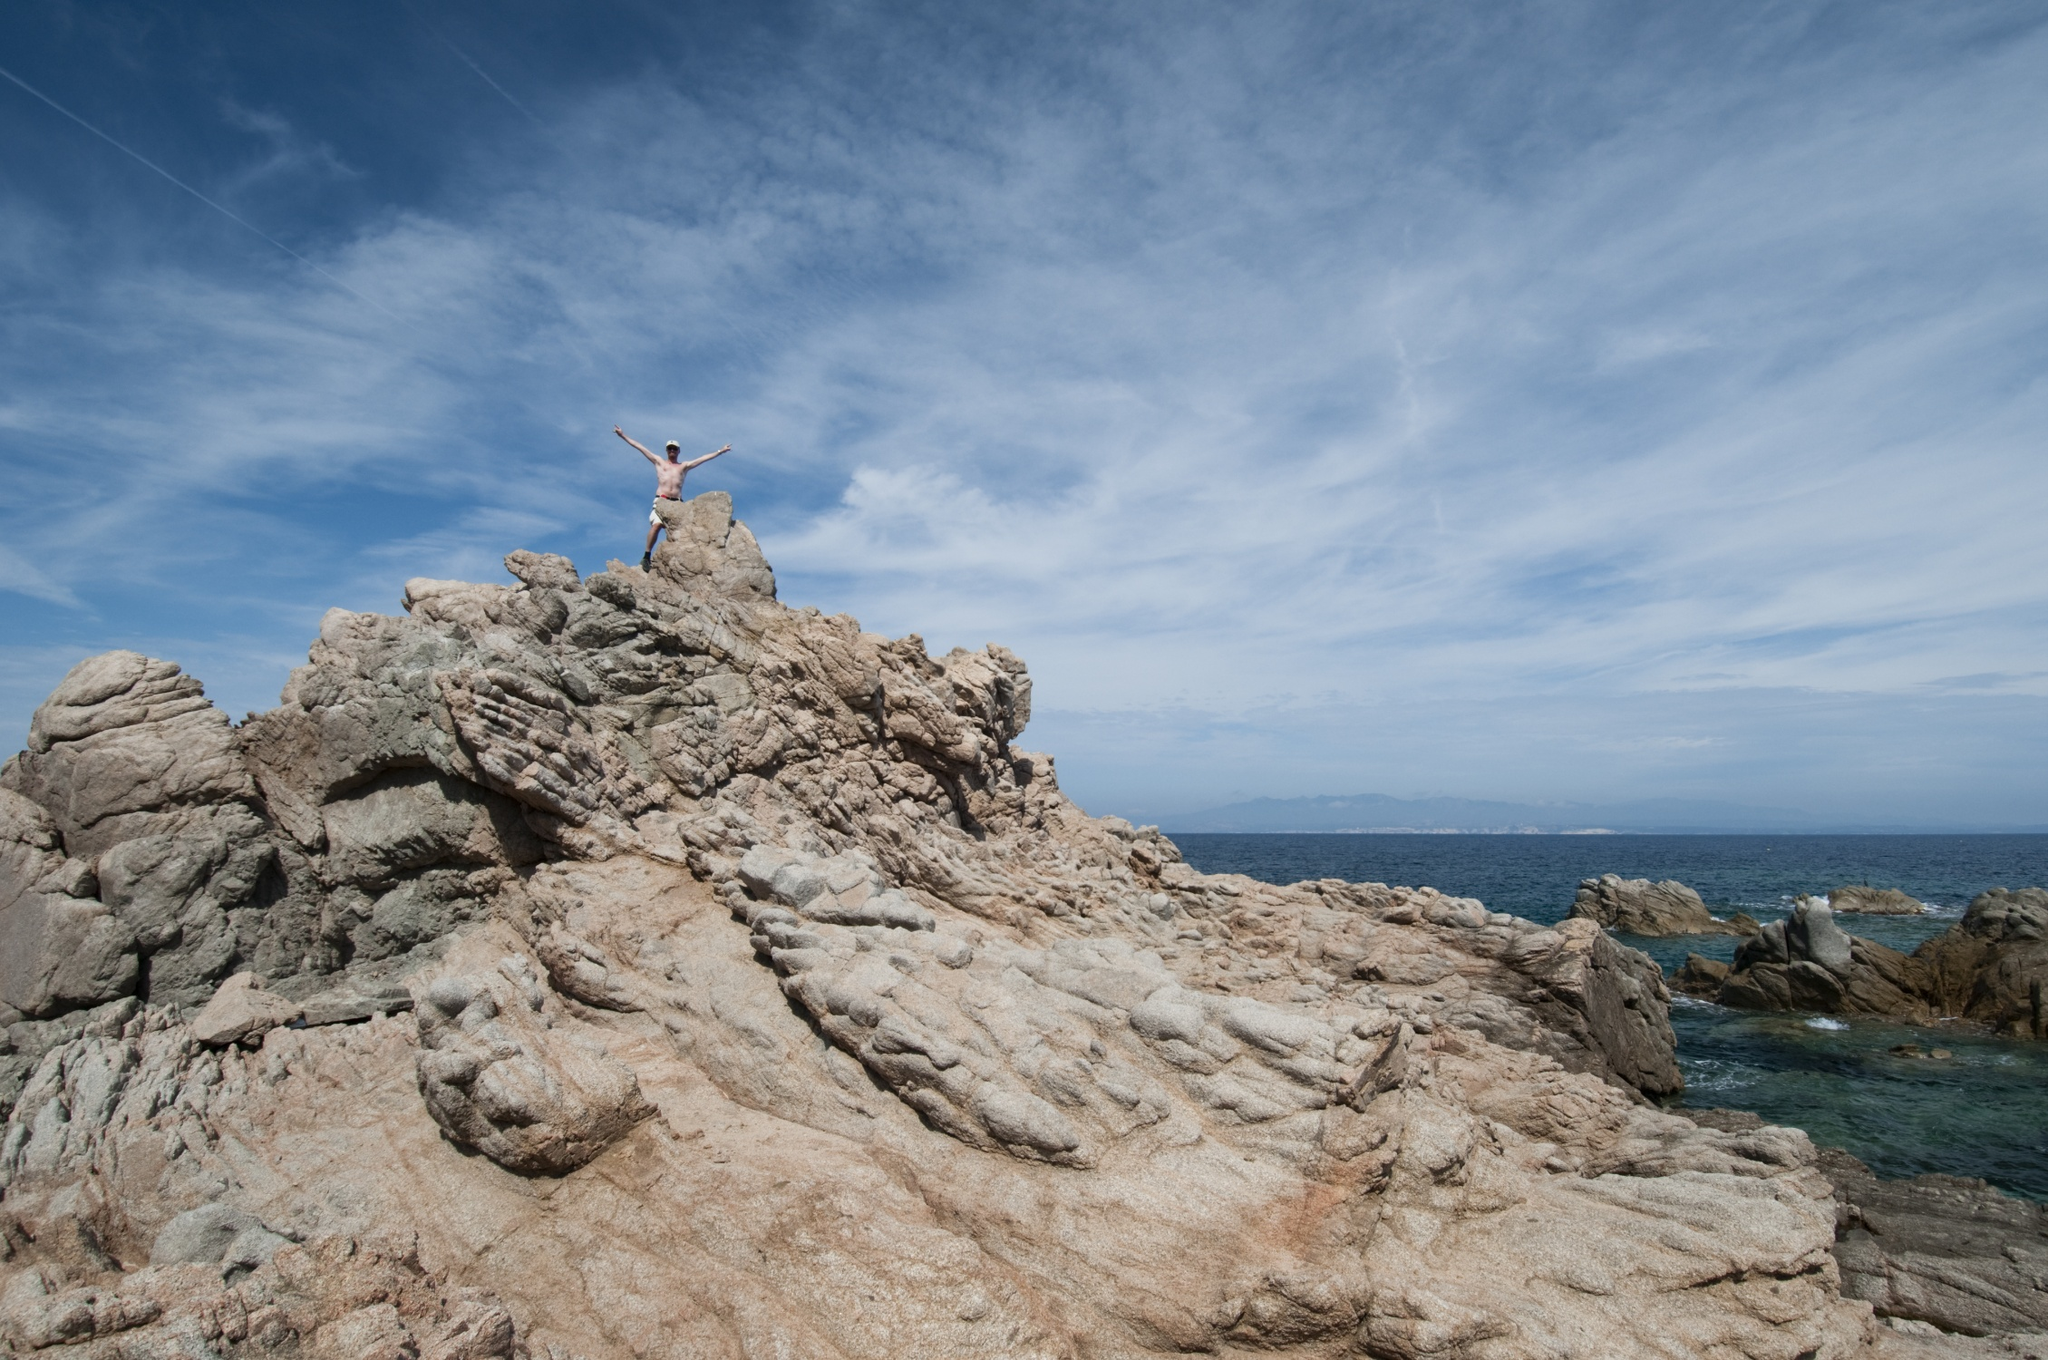What is this photo about? The image captures a striking and exhilarating scene of a person standing triumphantly on a rugged rocky cliff, overlooking the vast, shimmering expanse of the ocean. The individual has their arms outstretched in a victorious 'V' shape, as if embracing the boundless beauty of nature before them. The brilliant blue sky above, adorned with delicate wisps of clouds, adds an element of serenity to the picture. Below, the ocean stretches out to the horizon, its surface glistening under the sunlight, accentuating the majesty of the scene. The photograph is taken from a lower angle, amplifying the sense of grandeur and triumphant spirit conveyed by the person's pose. The contrast between the rugged, weathered rocks and the smooth, expansive ocean and sky creates a visually captivating and dynamic composition. This image encapsulates a moment of victory and freedom, beautifully framed by the natural elements. 